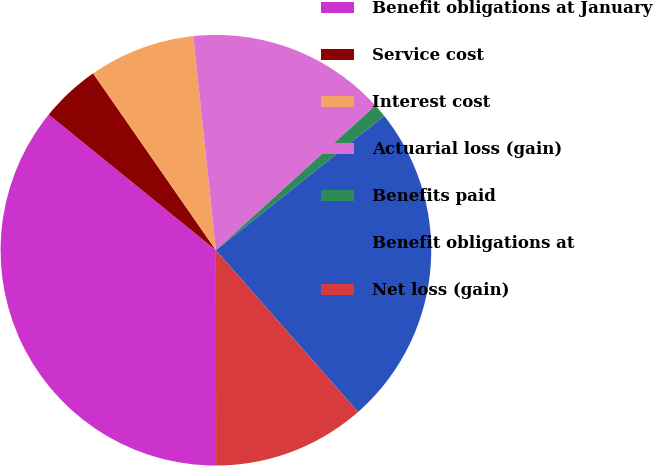Convert chart. <chart><loc_0><loc_0><loc_500><loc_500><pie_chart><fcel>Benefit obligations at January<fcel>Service cost<fcel>Interest cost<fcel>Actuarial loss (gain)<fcel>Benefits paid<fcel>Benefit obligations at<fcel>Net loss (gain)<nl><fcel>35.86%<fcel>4.49%<fcel>7.98%<fcel>14.95%<fcel>1.01%<fcel>24.24%<fcel>11.46%<nl></chart> 